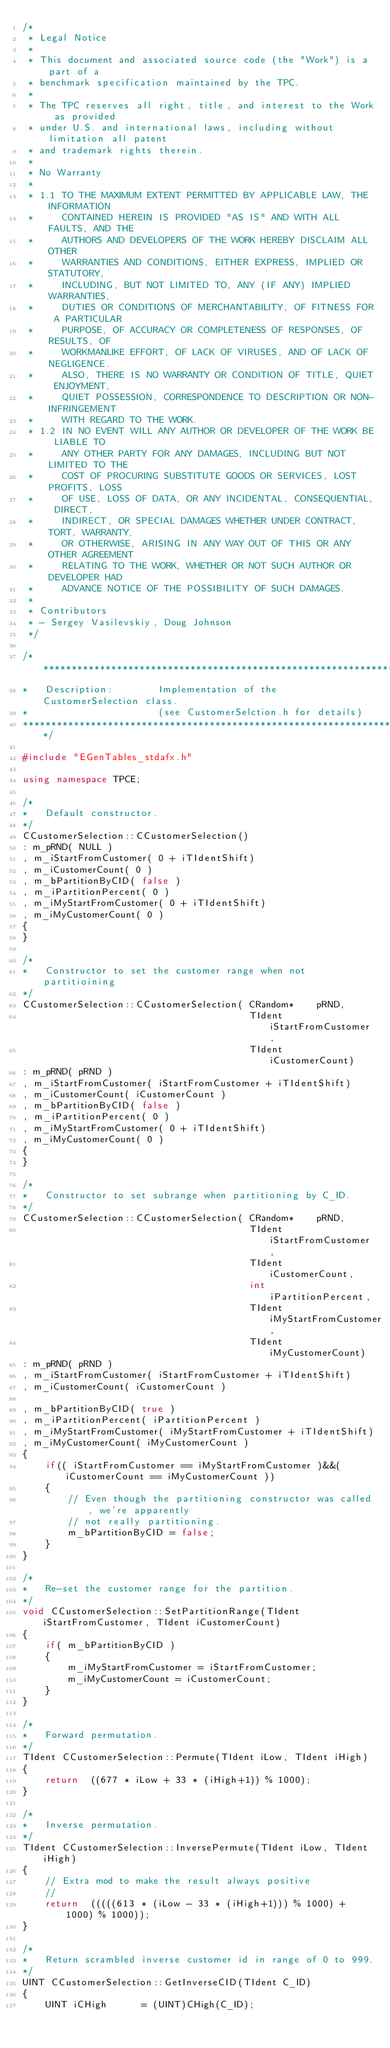<code> <loc_0><loc_0><loc_500><loc_500><_C++_>/*
 * Legal Notice
 *
 * This document and associated source code (the "Work") is a part of a
 * benchmark specification maintained by the TPC.
 *
 * The TPC reserves all right, title, and interest to the Work as provided
 * under U.S. and international laws, including without limitation all patent
 * and trademark rights therein.
 *
 * No Warranty
 *
 * 1.1 TO THE MAXIMUM EXTENT PERMITTED BY APPLICABLE LAW, THE INFORMATION
 *     CONTAINED HEREIN IS PROVIDED "AS IS" AND WITH ALL FAULTS, AND THE
 *     AUTHORS AND DEVELOPERS OF THE WORK HEREBY DISCLAIM ALL OTHER
 *     WARRANTIES AND CONDITIONS, EITHER EXPRESS, IMPLIED OR STATUTORY,
 *     INCLUDING, BUT NOT LIMITED TO, ANY (IF ANY) IMPLIED WARRANTIES,
 *     DUTIES OR CONDITIONS OF MERCHANTABILITY, OF FITNESS FOR A PARTICULAR
 *     PURPOSE, OF ACCURACY OR COMPLETENESS OF RESPONSES, OF RESULTS, OF
 *     WORKMANLIKE EFFORT, OF LACK OF VIRUSES, AND OF LACK OF NEGLIGENCE.
 *     ALSO, THERE IS NO WARRANTY OR CONDITION OF TITLE, QUIET ENJOYMENT,
 *     QUIET POSSESSION, CORRESPONDENCE TO DESCRIPTION OR NON-INFRINGEMENT
 *     WITH REGARD TO THE WORK.
 * 1.2 IN NO EVENT WILL ANY AUTHOR OR DEVELOPER OF THE WORK BE LIABLE TO
 *     ANY OTHER PARTY FOR ANY DAMAGES, INCLUDING BUT NOT LIMITED TO THE
 *     COST OF PROCURING SUBSTITUTE GOODS OR SERVICES, LOST PROFITS, LOSS
 *     OF USE, LOSS OF DATA, OR ANY INCIDENTAL, CONSEQUENTIAL, DIRECT,
 *     INDIRECT, OR SPECIAL DAMAGES WHETHER UNDER CONTRACT, TORT, WARRANTY,
 *     OR OTHERWISE, ARISING IN ANY WAY OUT OF THIS OR ANY OTHER AGREEMENT
 *     RELATING TO THE WORK, WHETHER OR NOT SUCH AUTHOR OR DEVELOPER HAD
 *     ADVANCE NOTICE OF THE POSSIBILITY OF SUCH DAMAGES.
 *
 * Contributors
 * - Sergey Vasilevskiy, Doug Johnson
 */

/******************************************************************************
*   Description:        Implementation of the CustomerSelection class.
*                       (see CustomerSelction.h for details)
******************************************************************************/

#include "EGenTables_stdafx.h"

using namespace TPCE;

/*
*   Default constructor.
*/
CCustomerSelection::CCustomerSelection()
: m_pRND( NULL )
, m_iStartFromCustomer( 0 + iTIdentShift)
, m_iCustomerCount( 0 )
, m_bPartitionByCID( false )
, m_iPartitionPercent( 0 )
, m_iMyStartFromCustomer( 0 + iTIdentShift)
, m_iMyCustomerCount( 0 )
{
}

/*
*   Constructor to set the customer range when not partitioining
*/
CCustomerSelection::CCustomerSelection( CRandom*    pRND,
                                        TIdent      iStartFromCustomer,
                                        TIdent      iCustomerCount)
: m_pRND( pRND )
, m_iStartFromCustomer( iStartFromCustomer + iTIdentShift)
, m_iCustomerCount( iCustomerCount )
, m_bPartitionByCID( false )
, m_iPartitionPercent( 0 )
, m_iMyStartFromCustomer( 0 + iTIdentShift)
, m_iMyCustomerCount( 0 )
{
}

/*
*   Constructor to set subrange when partitioning by C_ID.
*/
CCustomerSelection::CCustomerSelection( CRandom*    pRND,
                                        TIdent      iStartFromCustomer,
                                        TIdent      iCustomerCount,
                                        int         iPartitionPercent,
                                        TIdent      iMyStartFromCustomer,
                                        TIdent      iMyCustomerCount)
: m_pRND( pRND )
, m_iStartFromCustomer( iStartFromCustomer + iTIdentShift)
, m_iCustomerCount( iCustomerCount )

, m_bPartitionByCID( true )
, m_iPartitionPercent( iPartitionPercent )
, m_iMyStartFromCustomer( iMyStartFromCustomer + iTIdentShift)
, m_iMyCustomerCount( iMyCustomerCount )
{
    if(( iStartFromCustomer == iMyStartFromCustomer )&&( iCustomerCount == iMyCustomerCount ))
    {
        // Even though the partitioning constructor was called, we're apparently
        // not really partitioning.
        m_bPartitionByCID = false;
    }
}

/*
*   Re-set the customer range for the partition.
*/
void CCustomerSelection::SetPartitionRange(TIdent iStartFromCustomer, TIdent iCustomerCount)
{
    if( m_bPartitionByCID )
    {
        m_iMyStartFromCustomer = iStartFromCustomer;
        m_iMyCustomerCount = iCustomerCount;
    }
}

/*
*   Forward permutation.
*/
TIdent CCustomerSelection::Permute(TIdent iLow, TIdent iHigh)
{
    return  ((677 * iLow + 33 * (iHigh+1)) % 1000);
}

/*
*   Inverse permutation.
*/
TIdent CCustomerSelection::InversePermute(TIdent iLow, TIdent iHigh)
{
    // Extra mod to make the result always positive
    //
    return  (((((613 * (iLow - 33 * (iHigh+1))) % 1000) + 1000) % 1000));
}

/*
*   Return scrambled inverse customer id in range of 0 to 999.
*/
UINT CCustomerSelection::GetInverseCID(TIdent C_ID)
{
    UINT iCHigh      = (UINT)CHigh(C_ID);</code> 